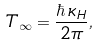<formula> <loc_0><loc_0><loc_500><loc_500>T _ { \infty } = \frac { \hbar { \, } \kappa _ { H } } { 2 \pi } ,</formula> 